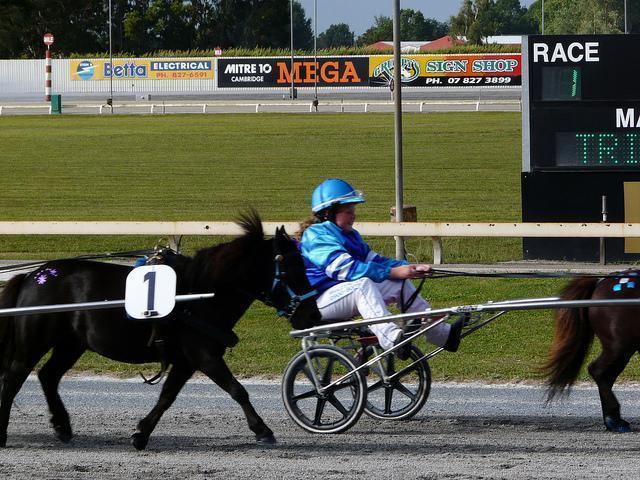What is this activity?
Select the accurate answer and provide justification: `Answer: choice
Rationale: srationale.`
Options: Musical, play, race, concert. Answer: race.
Rationale: A competition is happening since the horse is numbered. 